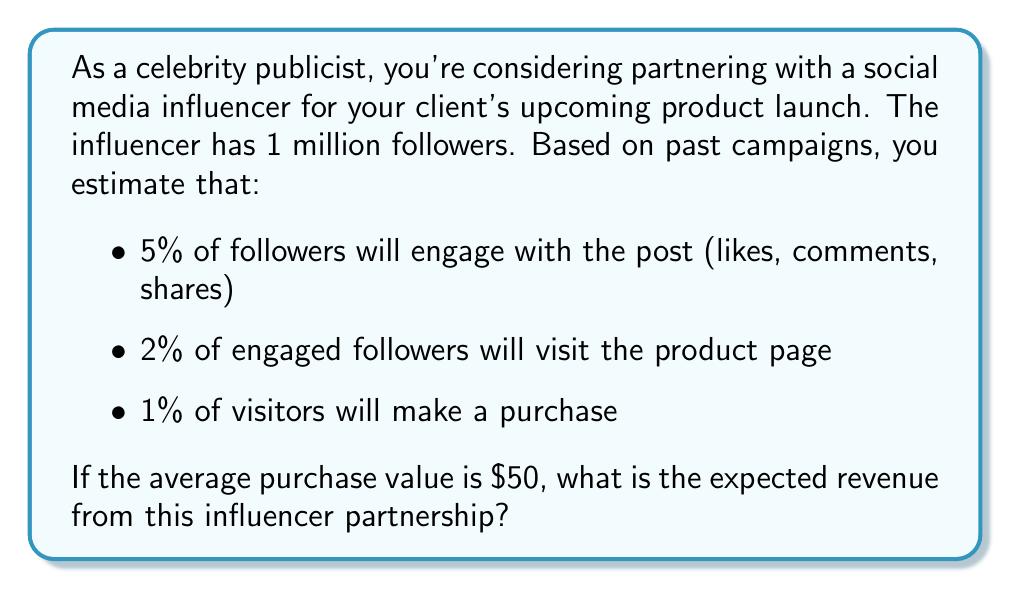What is the answer to this math problem? Let's break this down step-by-step:

1. Calculate the number of followers who will engage with the post:
   $$ \text{Engaged followers} = 1,000,000 \times 0.05 = 50,000 $$

2. Calculate the number of engaged followers who will visit the product page:
   $$ \text{Page visitors} = 50,000 \times 0.02 = 1,000 $$

3. Calculate the number of visitors who will make a purchase:
   $$ \text{Purchasers} = 1,000 \times 0.01 = 10 $$

4. Calculate the expected revenue:
   $$ \text{Expected Revenue} = \text{Purchasers} \times \text{Average Purchase Value} $$
   $$ \text{Expected Revenue} = 10 \times \$50 = \$500 $$

Therefore, the expected revenue from this influencer partnership is $500.
Answer: $500 